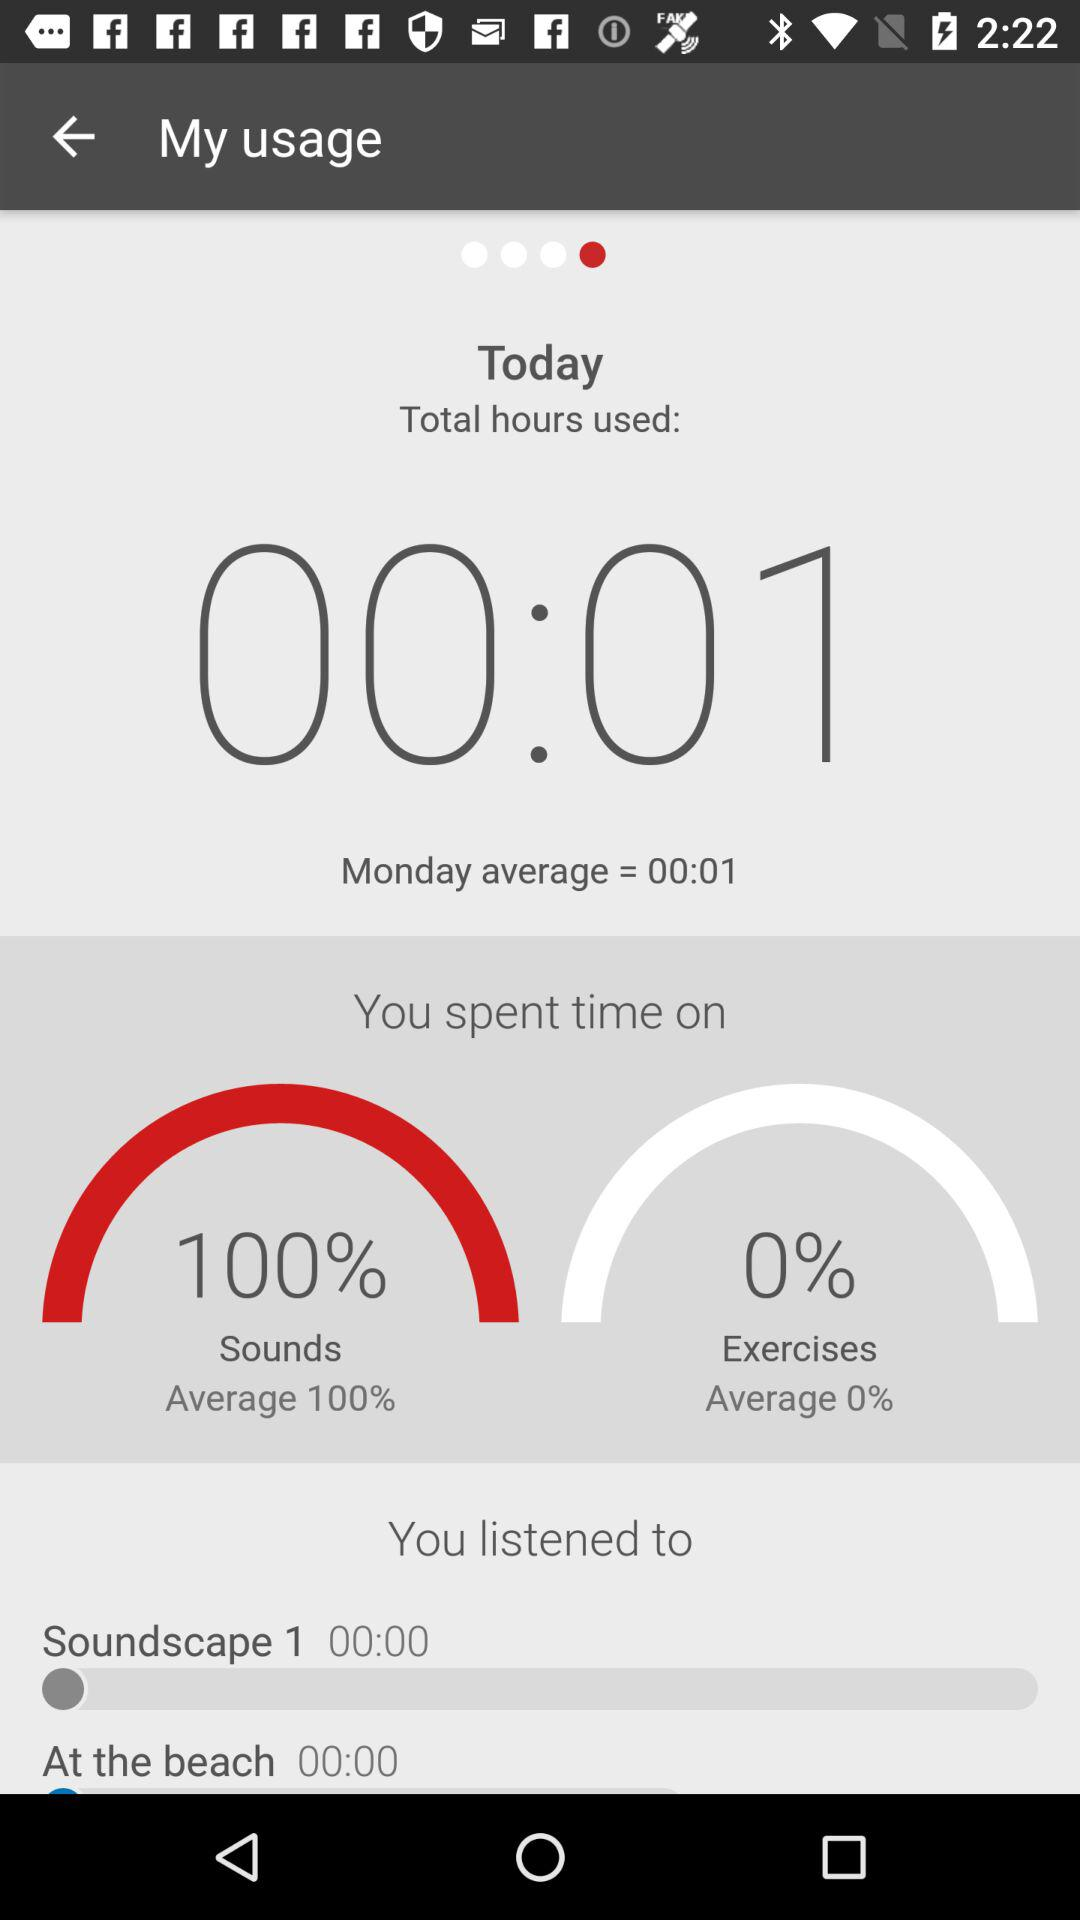What is the total number of hours spent on sounds and exercises?
Answer the question using a single word or phrase. 00:01 